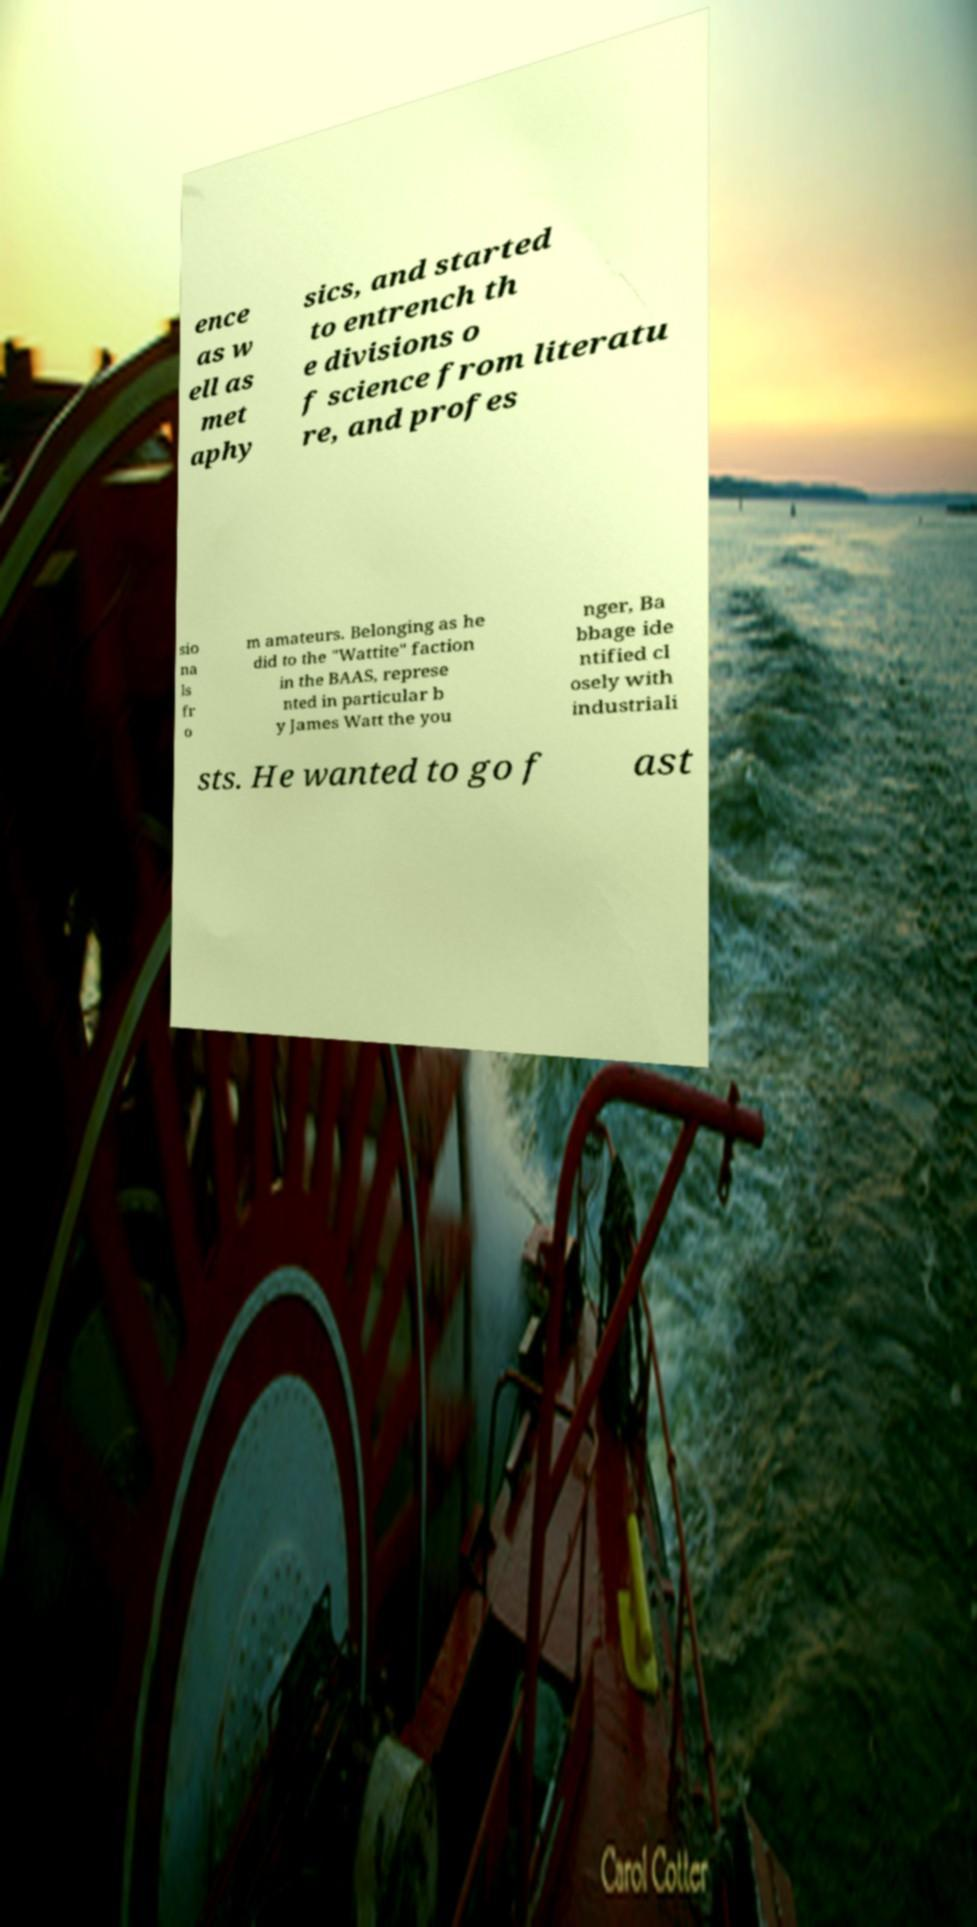For documentation purposes, I need the text within this image transcribed. Could you provide that? ence as w ell as met aphy sics, and started to entrench th e divisions o f science from literatu re, and profes sio na ls fr o m amateurs. Belonging as he did to the "Wattite" faction in the BAAS, represe nted in particular b y James Watt the you nger, Ba bbage ide ntified cl osely with industriali sts. He wanted to go f ast 